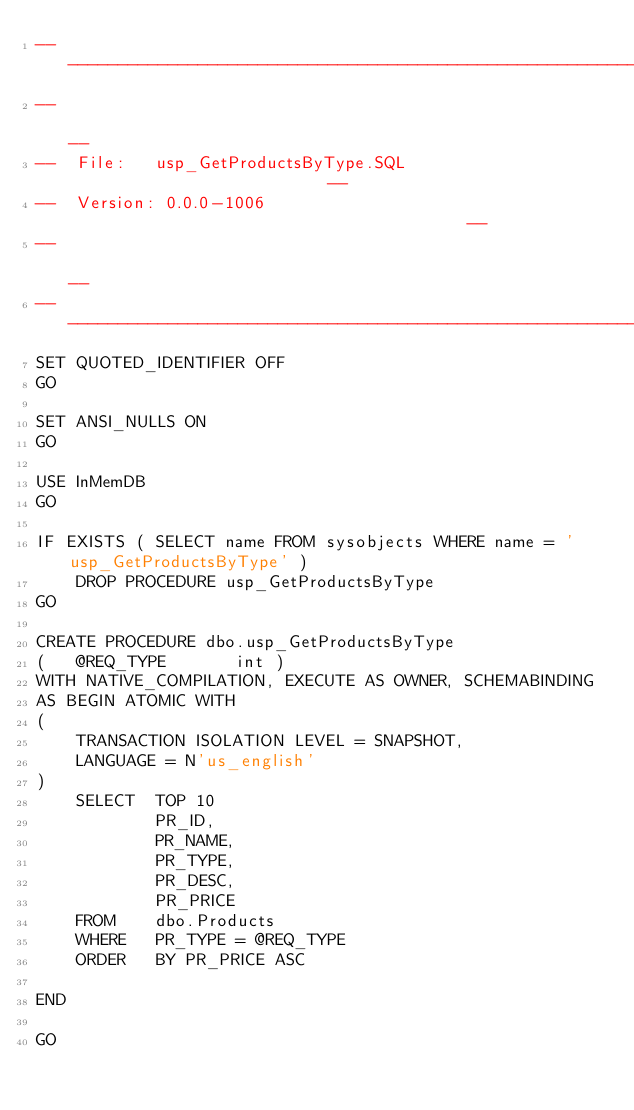Convert code to text. <code><loc_0><loc_0><loc_500><loc_500><_SQL_>------------------------------------------------------------------
--                                                              --
--  File:   usp_GetProductsByType.SQL                           --
--  Version: 0.0.0-1006                                         --
--                                                              --
------------------------------------------------------------------
SET QUOTED_IDENTIFIER OFF
GO

SET ANSI_NULLS ON
GO

USE InMemDB
GO

IF EXISTS ( SELECT name FROM sysobjects WHERE name = 'usp_GetProductsByType' )
    DROP PROCEDURE usp_GetProductsByType
GO

CREATE PROCEDURE dbo.usp_GetProductsByType
(	@REQ_TYPE		int )
WITH NATIVE_COMPILATION, EXECUTE AS OWNER, SCHEMABINDING
AS BEGIN ATOMIC WITH
(
    TRANSACTION ISOLATION LEVEL = SNAPSHOT,
    LANGUAGE = N'us_english'
)
	SELECT  TOP 10
            PR_ID,
	        PR_NAME,
	        PR_TYPE,
	        PR_DESC,
	        PR_PRICE
    FROM    dbo.Products
    WHERE   PR_TYPE = @REQ_TYPE
    ORDER   BY PR_PRICE ASC
   
END

GO
</code> 